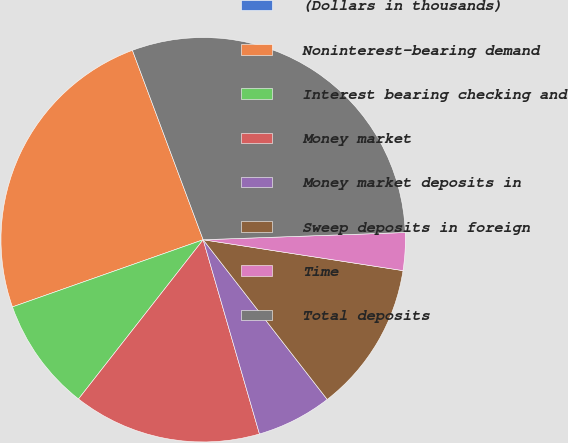Convert chart. <chart><loc_0><loc_0><loc_500><loc_500><pie_chart><fcel>(Dollars in thousands)<fcel>Noninterest-bearing demand<fcel>Interest bearing checking and<fcel>Money market<fcel>Money market deposits in<fcel>Sweep deposits in foreign<fcel>Time<fcel>Total deposits<nl><fcel>0.0%<fcel>24.7%<fcel>9.04%<fcel>15.06%<fcel>6.02%<fcel>12.05%<fcel>3.01%<fcel>30.12%<nl></chart> 